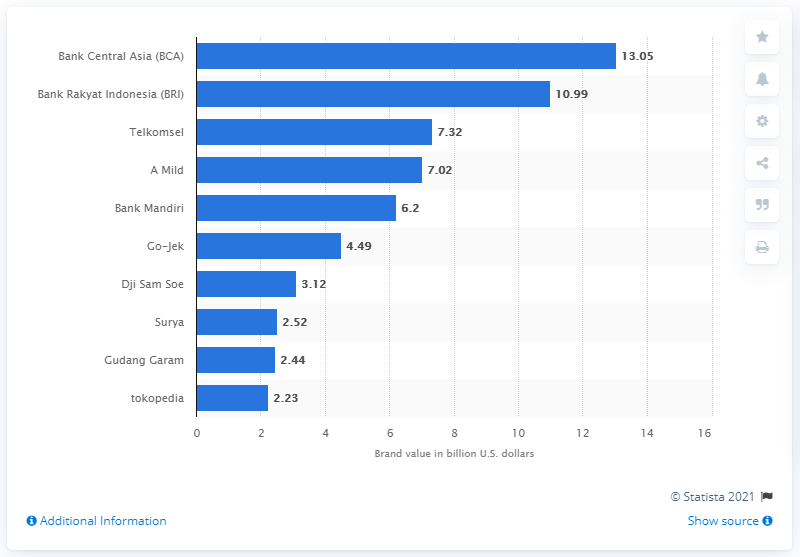Could you tell me which sector has the most number of brands in the top 10? Looking at the chart, it appears that the banking sector has the most number of brands in the top 10, with Bank Central Asia (BCA), Bank Rakyat Indonesia (BRI), and Bank Mandiri all featuring prominently. 